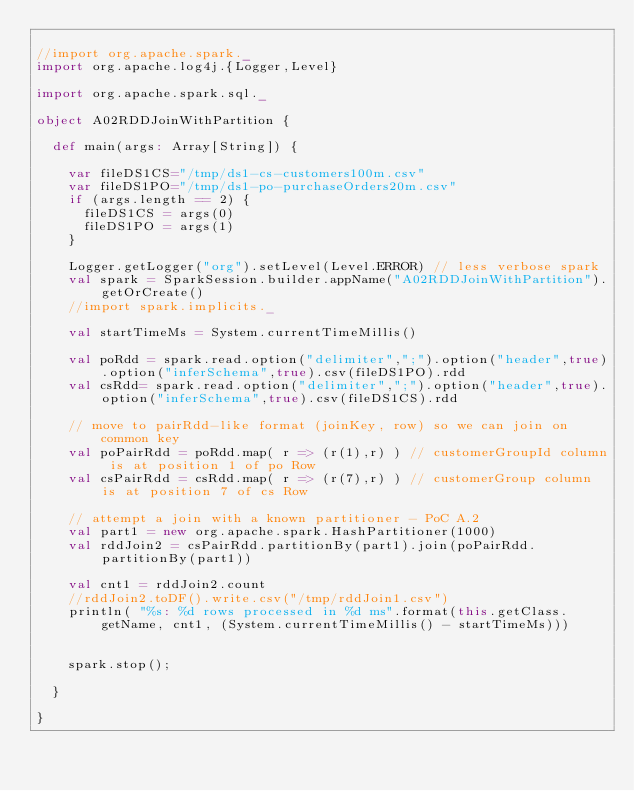Convert code to text. <code><loc_0><loc_0><loc_500><loc_500><_Scala_>
//import org.apache.spark._
import org.apache.log4j.{Logger,Level}

import org.apache.spark.sql._

object A02RDDJoinWithPartition {

  def main(args: Array[String]) {

    var fileDS1CS="/tmp/ds1-cs-customers100m.csv"
    var fileDS1PO="/tmp/ds1-po-purchaseOrders20m.csv"
    if (args.length == 2) {
      fileDS1CS = args(0)
      fileDS1PO = args(1)
    }

    Logger.getLogger("org").setLevel(Level.ERROR) // less verbose spark
    val spark = SparkSession.builder.appName("A02RDDJoinWithPartition").getOrCreate()
    //import spark.implicits._

    val startTimeMs = System.currentTimeMillis()

    val poRdd = spark.read.option("delimiter",";").option("header",true).option("inferSchema",true).csv(fileDS1PO).rdd
    val csRdd= spark.read.option("delimiter",";").option("header",true).option("inferSchema",true).csv(fileDS1CS).rdd

    // move to pairRdd-like format (joinKey, row) so we can join on common key
    val poPairRdd = poRdd.map( r => (r(1),r) ) // customerGroupId column is at position 1 of po Row
    val csPairRdd = csRdd.map( r => (r(7),r) ) // customerGroup column is at position 7 of cs Row

    // attempt a join with a known partitioner - PoC A.2
    val part1 = new org.apache.spark.HashPartitioner(1000)
    val rddJoin2 = csPairRdd.partitionBy(part1).join(poPairRdd.partitionBy(part1))

    val cnt1 = rddJoin2.count
    //rddJoin2.toDF().write.csv("/tmp/rddJoin1.csv")
    println( "%s: %d rows processed in %d ms".format(this.getClass.getName, cnt1, (System.currentTimeMillis() - startTimeMs)))


    spark.stop();

  }

}
</code> 